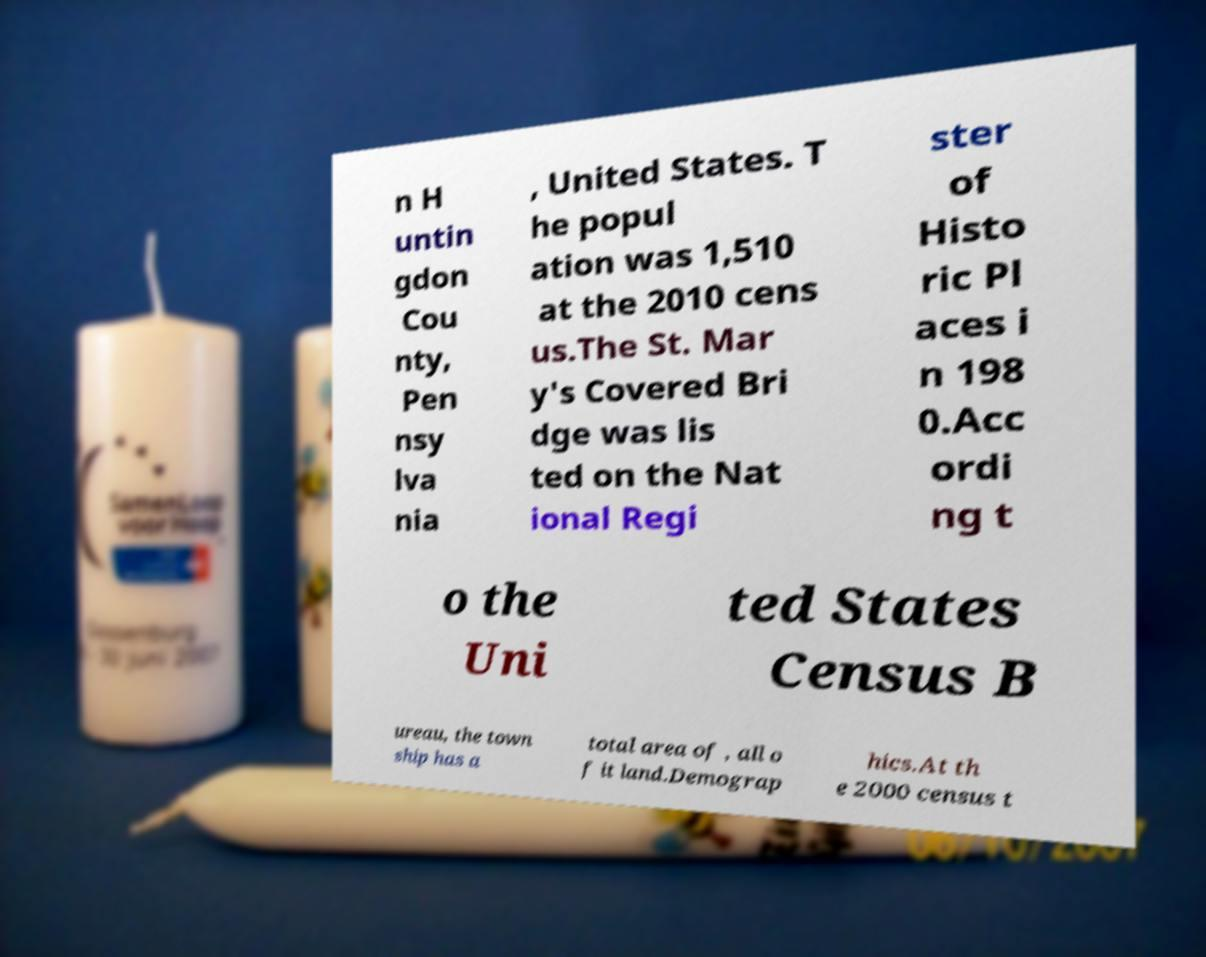I need the written content from this picture converted into text. Can you do that? n H untin gdon Cou nty, Pen nsy lva nia , United States. T he popul ation was 1,510 at the 2010 cens us.The St. Mar y's Covered Bri dge was lis ted on the Nat ional Regi ster of Histo ric Pl aces i n 198 0.Acc ordi ng t o the Uni ted States Census B ureau, the town ship has a total area of , all o f it land.Demograp hics.At th e 2000 census t 